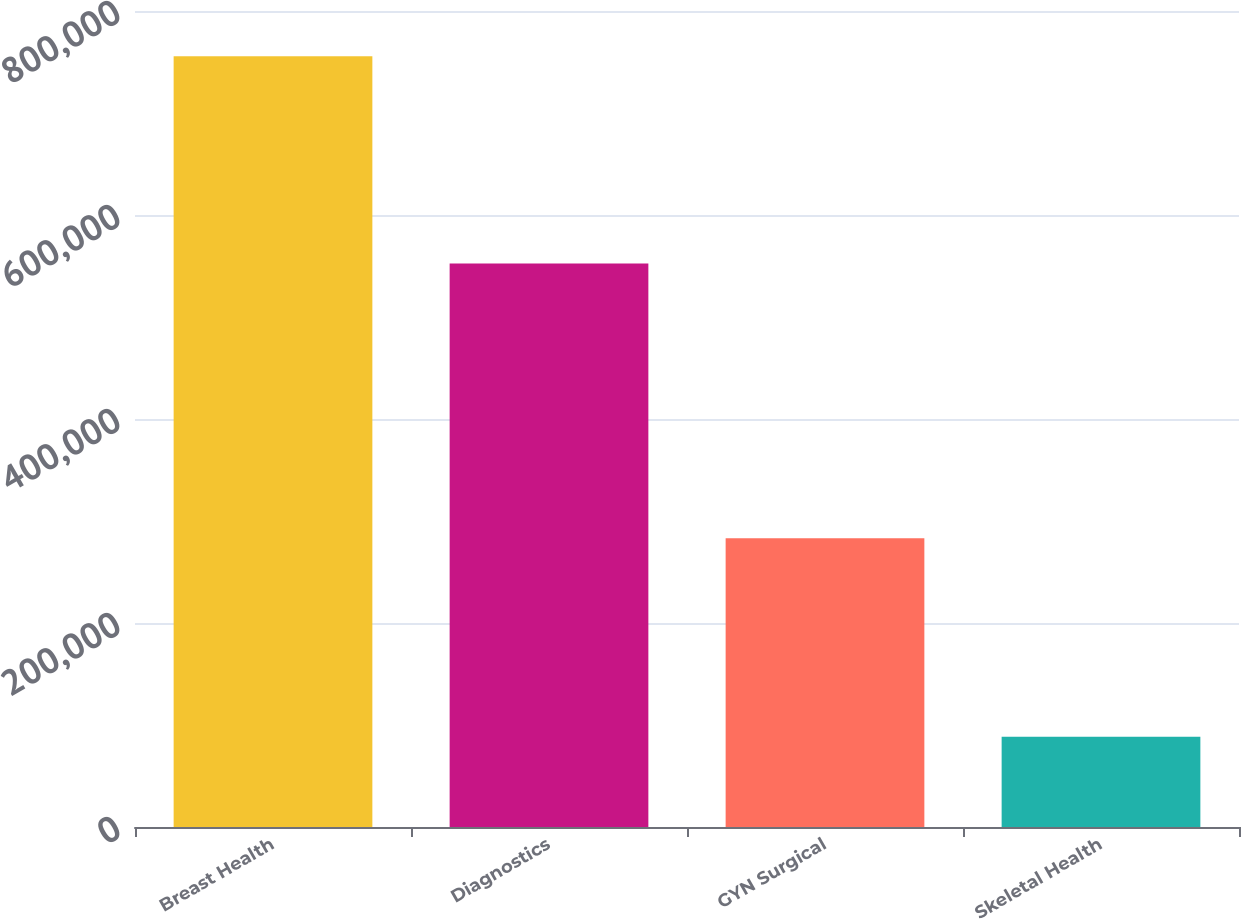<chart> <loc_0><loc_0><loc_500><loc_500><bar_chart><fcel>Breast Health<fcel>Diagnostics<fcel>GYN Surgical<fcel>Skeletal Health<nl><fcel>755542<fcel>552501<fcel>283142<fcel>88367<nl></chart> 